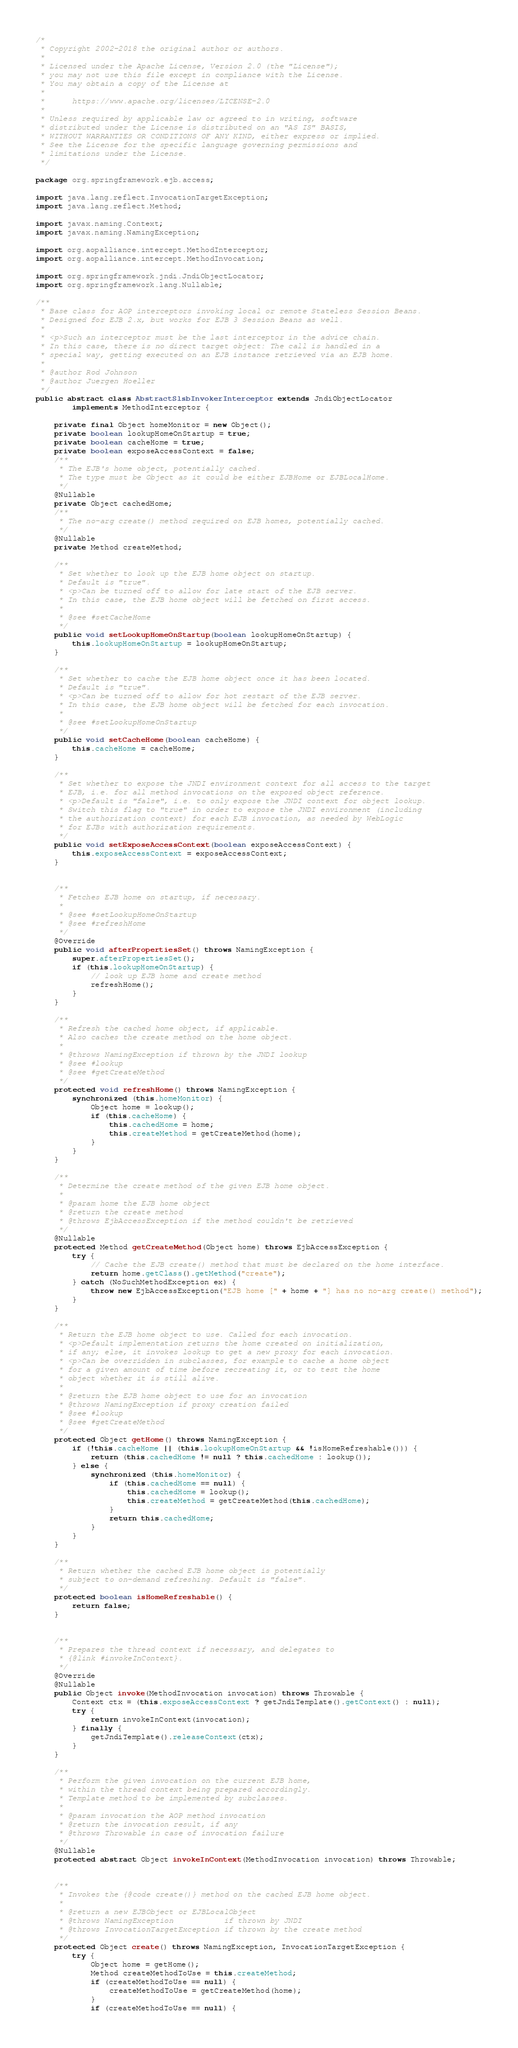Convert code to text. <code><loc_0><loc_0><loc_500><loc_500><_Java_>/*
 * Copyright 2002-2018 the original author or authors.
 *
 * Licensed under the Apache License, Version 2.0 (the "License");
 * you may not use this file except in compliance with the License.
 * You may obtain a copy of the License at
 *
 *      https://www.apache.org/licenses/LICENSE-2.0
 *
 * Unless required by applicable law or agreed to in writing, software
 * distributed under the License is distributed on an "AS IS" BASIS,
 * WITHOUT WARRANTIES OR CONDITIONS OF ANY KIND, either express or implied.
 * See the License for the specific language governing permissions and
 * limitations under the License.
 */

package org.springframework.ejb.access;

import java.lang.reflect.InvocationTargetException;
import java.lang.reflect.Method;

import javax.naming.Context;
import javax.naming.NamingException;

import org.aopalliance.intercept.MethodInterceptor;
import org.aopalliance.intercept.MethodInvocation;

import org.springframework.jndi.JndiObjectLocator;
import org.springframework.lang.Nullable;

/**
 * Base class for AOP interceptors invoking local or remote Stateless Session Beans.
 * Designed for EJB 2.x, but works for EJB 3 Session Beans as well.
 *
 * <p>Such an interceptor must be the last interceptor in the advice chain.
 * In this case, there is no direct target object: The call is handled in a
 * special way, getting executed on an EJB instance retrieved via an EJB home.
 *
 * @author Rod Johnson
 * @author Juergen Hoeller
 */
public abstract class AbstractSlsbInvokerInterceptor extends JndiObjectLocator
		implements MethodInterceptor {

	private final Object homeMonitor = new Object();
	private boolean lookupHomeOnStartup = true;
	private boolean cacheHome = true;
	private boolean exposeAccessContext = false;
	/**
	 * The EJB's home object, potentially cached.
	 * The type must be Object as it could be either EJBHome or EJBLocalHome.
	 */
	@Nullable
	private Object cachedHome;
	/**
	 * The no-arg create() method required on EJB homes, potentially cached.
	 */
	@Nullable
	private Method createMethod;

	/**
	 * Set whether to look up the EJB home object on startup.
	 * Default is "true".
	 * <p>Can be turned off to allow for late start of the EJB server.
	 * In this case, the EJB home object will be fetched on first access.
	 *
	 * @see #setCacheHome
	 */
	public void setLookupHomeOnStartup(boolean lookupHomeOnStartup) {
		this.lookupHomeOnStartup = lookupHomeOnStartup;
	}

	/**
	 * Set whether to cache the EJB home object once it has been located.
	 * Default is "true".
	 * <p>Can be turned off to allow for hot restart of the EJB server.
	 * In this case, the EJB home object will be fetched for each invocation.
	 *
	 * @see #setLookupHomeOnStartup
	 */
	public void setCacheHome(boolean cacheHome) {
		this.cacheHome = cacheHome;
	}

	/**
	 * Set whether to expose the JNDI environment context for all access to the target
	 * EJB, i.e. for all method invocations on the exposed object reference.
	 * <p>Default is "false", i.e. to only expose the JNDI context for object lookup.
	 * Switch this flag to "true" in order to expose the JNDI environment (including
	 * the authorization context) for each EJB invocation, as needed by WebLogic
	 * for EJBs with authorization requirements.
	 */
	public void setExposeAccessContext(boolean exposeAccessContext) {
		this.exposeAccessContext = exposeAccessContext;
	}


	/**
	 * Fetches EJB home on startup, if necessary.
	 *
	 * @see #setLookupHomeOnStartup
	 * @see #refreshHome
	 */
	@Override
	public void afterPropertiesSet() throws NamingException {
		super.afterPropertiesSet();
		if (this.lookupHomeOnStartup) {
			// look up EJB home and create method
			refreshHome();
		}
	}

	/**
	 * Refresh the cached home object, if applicable.
	 * Also caches the create method on the home object.
	 *
	 * @throws NamingException if thrown by the JNDI lookup
	 * @see #lookup
	 * @see #getCreateMethod
	 */
	protected void refreshHome() throws NamingException {
		synchronized (this.homeMonitor) {
			Object home = lookup();
			if (this.cacheHome) {
				this.cachedHome = home;
				this.createMethod = getCreateMethod(home);
			}
		}
	}

	/**
	 * Determine the create method of the given EJB home object.
	 *
	 * @param home the EJB home object
	 * @return the create method
	 * @throws EjbAccessException if the method couldn't be retrieved
	 */
	@Nullable
	protected Method getCreateMethod(Object home) throws EjbAccessException {
		try {
			// Cache the EJB create() method that must be declared on the home interface.
			return home.getClass().getMethod("create");
		} catch (NoSuchMethodException ex) {
			throw new EjbAccessException("EJB home [" + home + "] has no no-arg create() method");
		}
	}

	/**
	 * Return the EJB home object to use. Called for each invocation.
	 * <p>Default implementation returns the home created on initialization,
	 * if any; else, it invokes lookup to get a new proxy for each invocation.
	 * <p>Can be overridden in subclasses, for example to cache a home object
	 * for a given amount of time before recreating it, or to test the home
	 * object whether it is still alive.
	 *
	 * @return the EJB home object to use for an invocation
	 * @throws NamingException if proxy creation failed
	 * @see #lookup
	 * @see #getCreateMethod
	 */
	protected Object getHome() throws NamingException {
		if (!this.cacheHome || (this.lookupHomeOnStartup && !isHomeRefreshable())) {
			return (this.cachedHome != null ? this.cachedHome : lookup());
		} else {
			synchronized (this.homeMonitor) {
				if (this.cachedHome == null) {
					this.cachedHome = lookup();
					this.createMethod = getCreateMethod(this.cachedHome);
				}
				return this.cachedHome;
			}
		}
	}

	/**
	 * Return whether the cached EJB home object is potentially
	 * subject to on-demand refreshing. Default is "false".
	 */
	protected boolean isHomeRefreshable() {
		return false;
	}


	/**
	 * Prepares the thread context if necessary, and delegates to
	 * {@link #invokeInContext}.
	 */
	@Override
	@Nullable
	public Object invoke(MethodInvocation invocation) throws Throwable {
		Context ctx = (this.exposeAccessContext ? getJndiTemplate().getContext() : null);
		try {
			return invokeInContext(invocation);
		} finally {
			getJndiTemplate().releaseContext(ctx);
		}
	}

	/**
	 * Perform the given invocation on the current EJB home,
	 * within the thread context being prepared accordingly.
	 * Template method to be implemented by subclasses.
	 *
	 * @param invocation the AOP method invocation
	 * @return the invocation result, if any
	 * @throws Throwable in case of invocation failure
	 */
	@Nullable
	protected abstract Object invokeInContext(MethodInvocation invocation) throws Throwable;


	/**
	 * Invokes the {@code create()} method on the cached EJB home object.
	 *
	 * @return a new EJBObject or EJBLocalObject
	 * @throws NamingException           if thrown by JNDI
	 * @throws InvocationTargetException if thrown by the create method
	 */
	protected Object create() throws NamingException, InvocationTargetException {
		try {
			Object home = getHome();
			Method createMethodToUse = this.createMethod;
			if (createMethodToUse == null) {
				createMethodToUse = getCreateMethod(home);
			}
			if (createMethodToUse == null) {</code> 